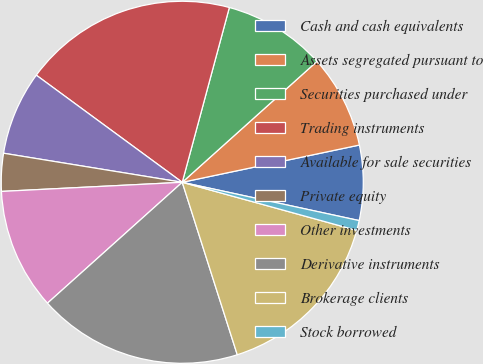<chart> <loc_0><loc_0><loc_500><loc_500><pie_chart><fcel>Cash and cash equivalents<fcel>Assets segregated pursuant to<fcel>Securities purchased under<fcel>Trading instruments<fcel>Available for sale securities<fcel>Private equity<fcel>Other investments<fcel>Derivative instruments<fcel>Brokerage clients<fcel>Stock borrowed<nl><fcel>6.69%<fcel>8.34%<fcel>9.17%<fcel>19.11%<fcel>7.51%<fcel>3.37%<fcel>10.83%<fcel>18.28%<fcel>15.8%<fcel>0.89%<nl></chart> 